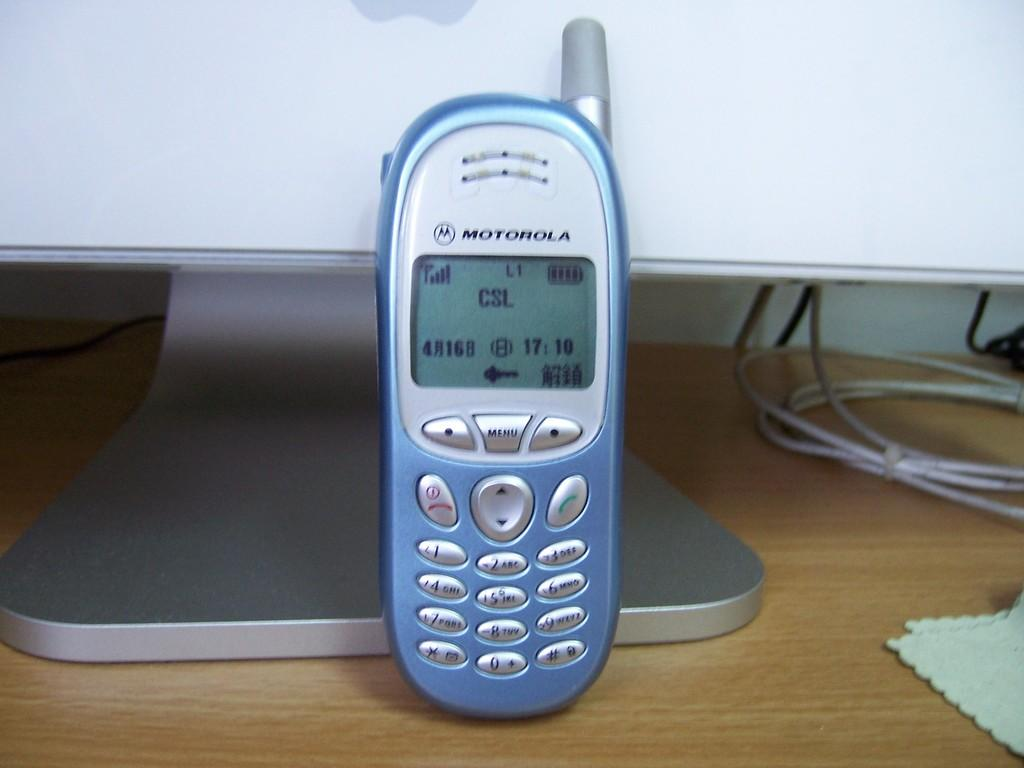<image>
Relay a brief, clear account of the picture shown. Blue Motorola cell phone with a black and white screen 